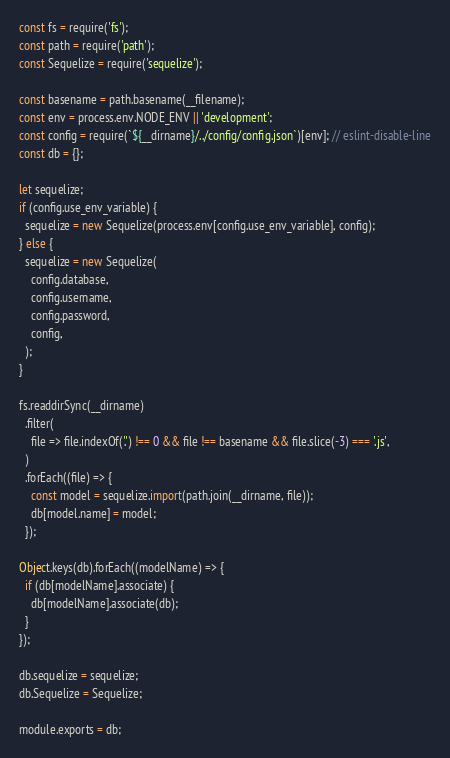<code> <loc_0><loc_0><loc_500><loc_500><_JavaScript_>const fs = require('fs');
const path = require('path');
const Sequelize = require('sequelize');

const basename = path.basename(__filename);
const env = process.env.NODE_ENV || 'development';
const config = require(`${__dirname}/../config/config.json`)[env]; // eslint-disable-line
const db = {};

let sequelize;
if (config.use_env_variable) {
  sequelize = new Sequelize(process.env[config.use_env_variable], config);
} else {
  sequelize = new Sequelize(
    config.database,
    config.username,
    config.password,
    config,
  );
}

fs.readdirSync(__dirname)
  .filter(
    file => file.indexOf('.') !== 0 && file !== basename && file.slice(-3) === '.js',
  )
  .forEach((file) => {
    const model = sequelize.import(path.join(__dirname, file));
    db[model.name] = model;
  });

Object.keys(db).forEach((modelName) => {
  if (db[modelName].associate) {
    db[modelName].associate(db);
  }
});

db.sequelize = sequelize;
db.Sequelize = Sequelize;

module.exports = db;
</code> 